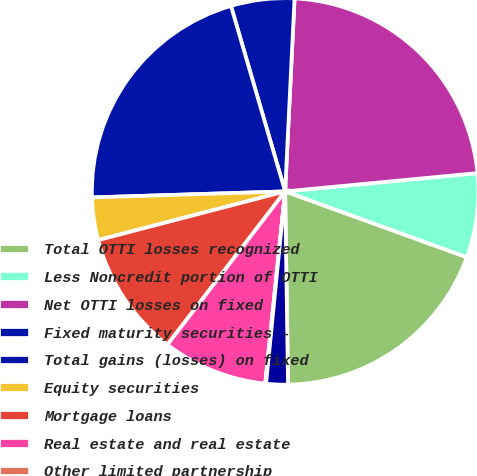Convert chart to OTSL. <chart><loc_0><loc_0><loc_500><loc_500><pie_chart><fcel>Total OTTI losses recognized<fcel>Less Noncredit portion of OTTI<fcel>Net OTTI losses on fixed<fcel>Fixed maturity securities -<fcel>Total gains (losses) on fixed<fcel>Equity securities<fcel>Mortgage loans<fcel>Real estate and real estate<fcel>Other limited partnership<fcel>Other investment portfolio<nl><fcel>19.23%<fcel>7.04%<fcel>22.71%<fcel>5.3%<fcel>20.97%<fcel>3.56%<fcel>10.52%<fcel>8.78%<fcel>0.07%<fcel>1.81%<nl></chart> 